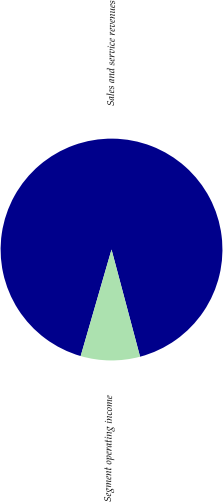<chart> <loc_0><loc_0><loc_500><loc_500><pie_chart><fcel>Sales and service revenues<fcel>Segment operating income<nl><fcel>91.37%<fcel>8.63%<nl></chart> 